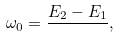<formula> <loc_0><loc_0><loc_500><loc_500>\omega _ { 0 } = \frac { E _ { 2 } - E _ { 1 } } { } ,</formula> 